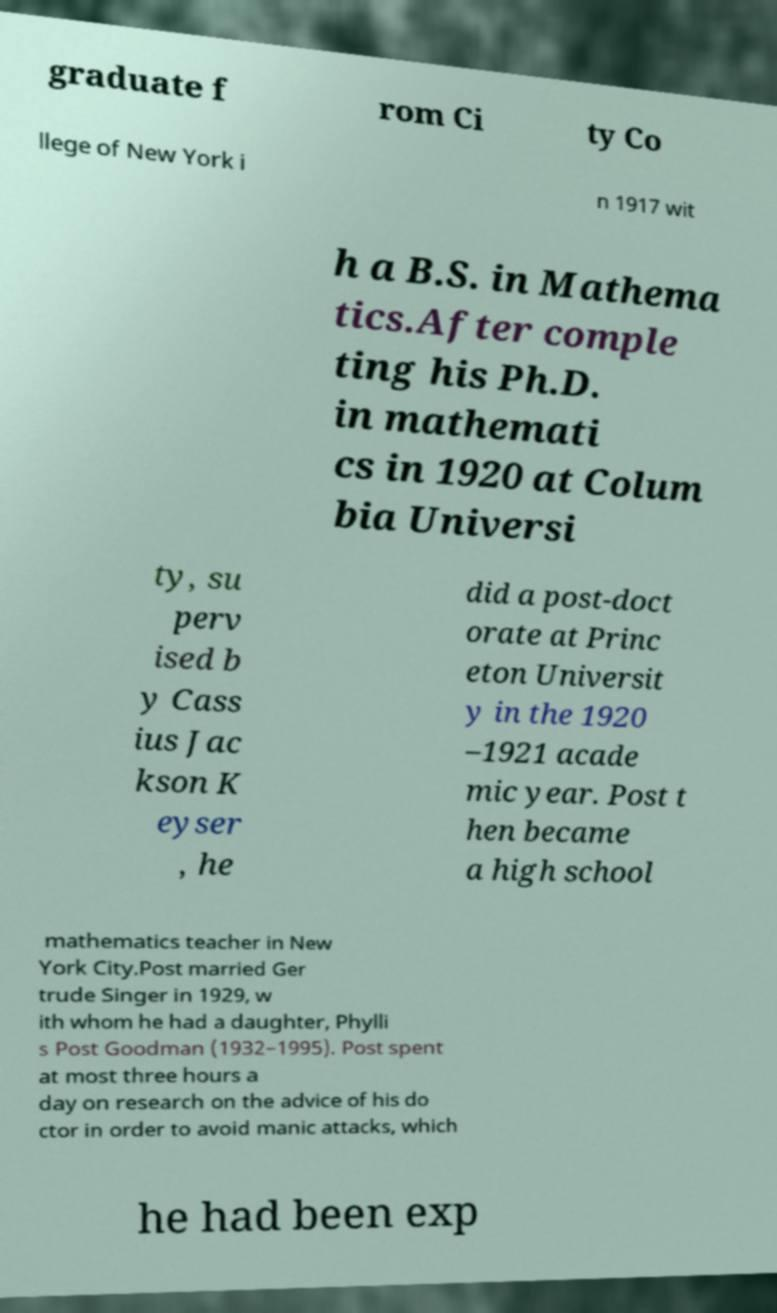Please read and relay the text visible in this image. What does it say? graduate f rom Ci ty Co llege of New York i n 1917 wit h a B.S. in Mathema tics.After comple ting his Ph.D. in mathemati cs in 1920 at Colum bia Universi ty, su perv ised b y Cass ius Jac kson K eyser , he did a post-doct orate at Princ eton Universit y in the 1920 –1921 acade mic year. Post t hen became a high school mathematics teacher in New York City.Post married Ger trude Singer in 1929, w ith whom he had a daughter, Phylli s Post Goodman (1932–1995). Post spent at most three hours a day on research on the advice of his do ctor in order to avoid manic attacks, which he had been exp 